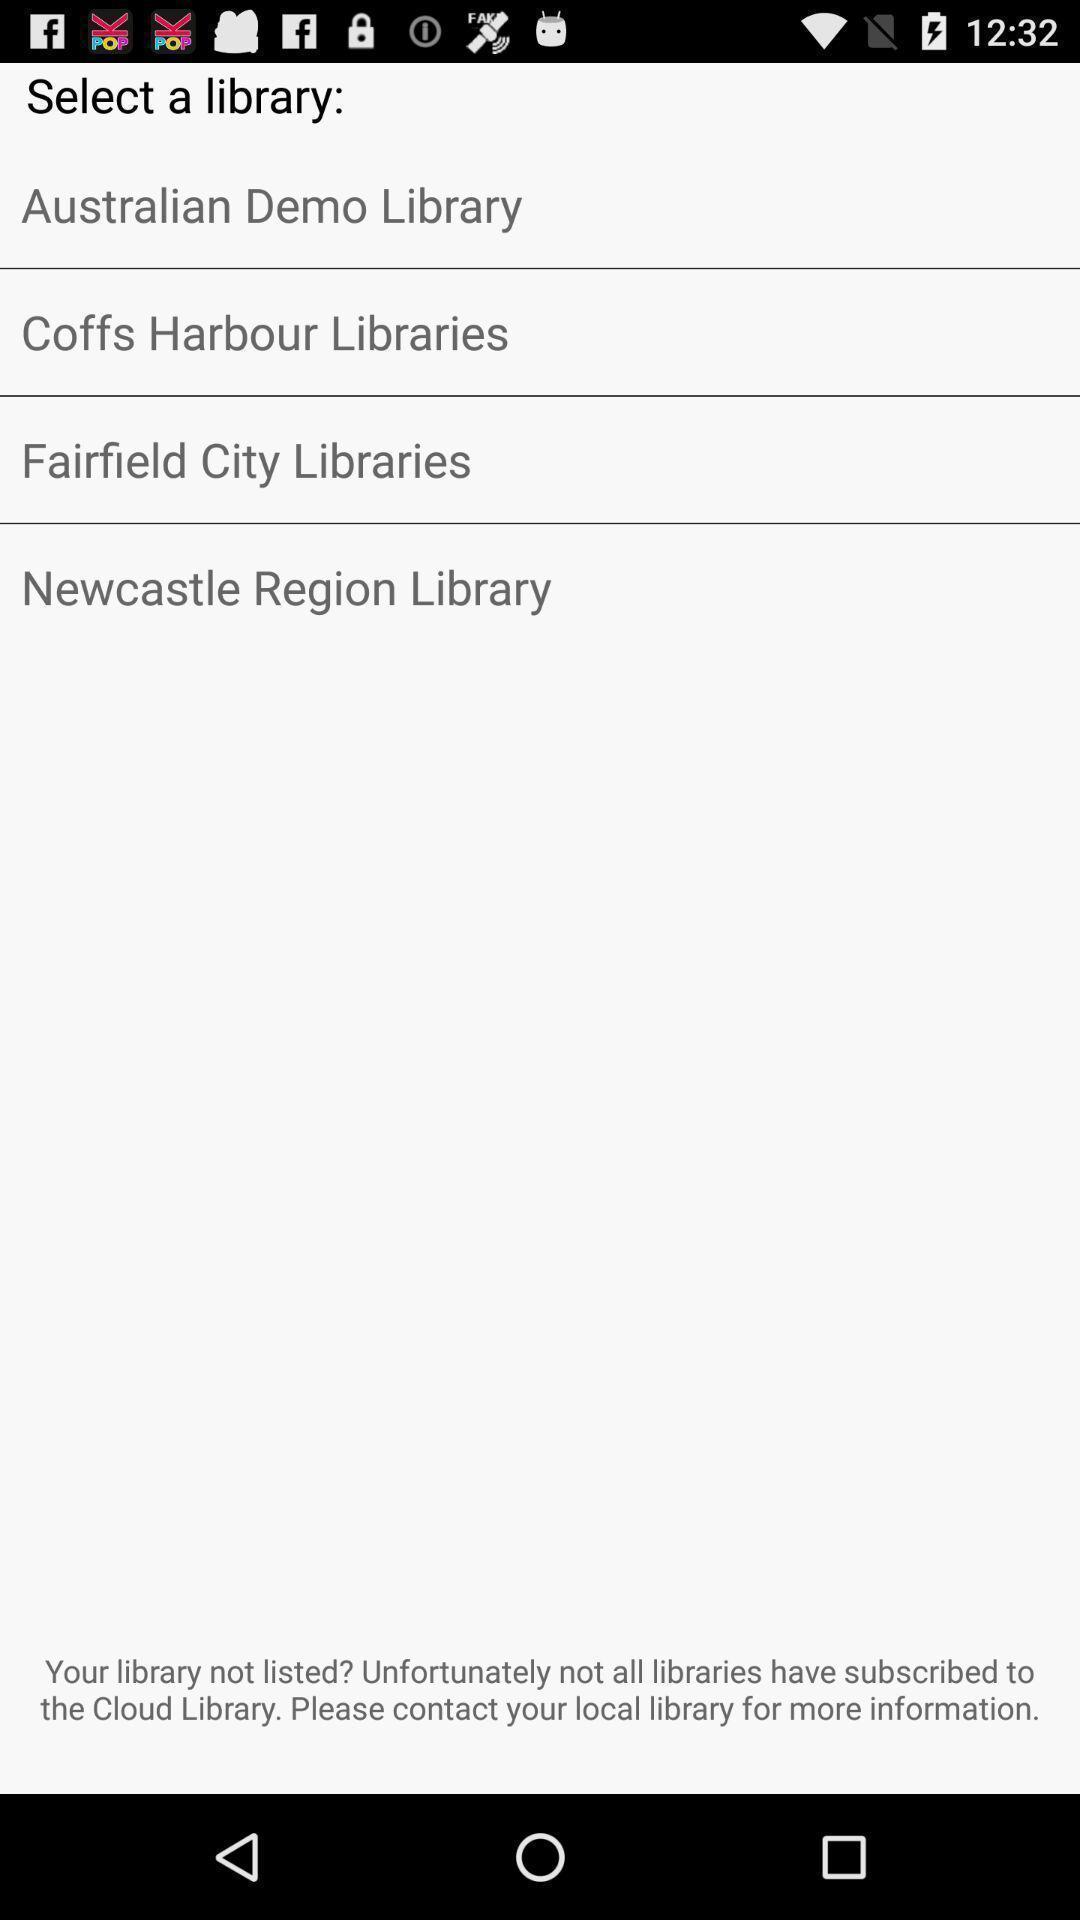Explain the elements present in this screenshot. Screen displaying the list of libraries. 